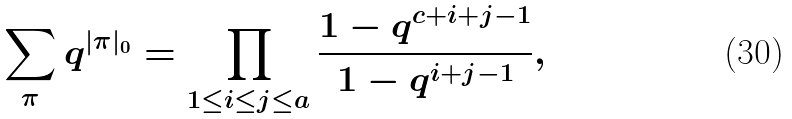Convert formula to latex. <formula><loc_0><loc_0><loc_500><loc_500>\sum _ { \pi } q ^ { | \pi | _ { 0 } } = \prod _ { 1 \leq i \leq j \leq a } \frac { 1 - q ^ { c + i + j - 1 } } { 1 - q ^ { i + j - 1 } } ,</formula> 